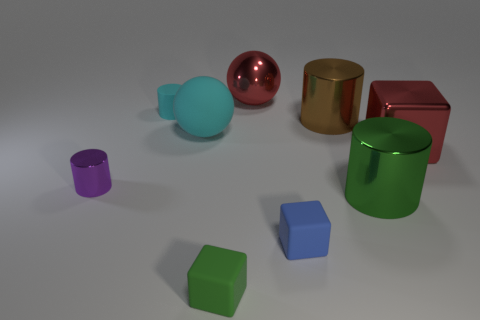What is the color of the other object that is the same shape as the big matte object?
Your response must be concise. Red. There is a big red thing to the left of the big shiny cube; what number of large metal objects are behind it?
Offer a very short reply. 0. How many cylinders are either purple objects or green rubber things?
Offer a terse response. 1. Are there any purple shiny objects?
Keep it short and to the point. Yes. The green object that is the same shape as the tiny purple object is what size?
Offer a terse response. Large. There is a tiny purple metallic object that is in front of the large sphere right of the large cyan ball; what is its shape?
Make the answer very short. Cylinder. What number of red objects are tiny cubes or shiny cylinders?
Ensure brevity in your answer.  0. What color is the small shiny cylinder?
Your answer should be very brief. Purple. Is the red cube the same size as the green cube?
Your answer should be very brief. No. Are there any other things that have the same shape as the small blue rubber object?
Your response must be concise. Yes. 